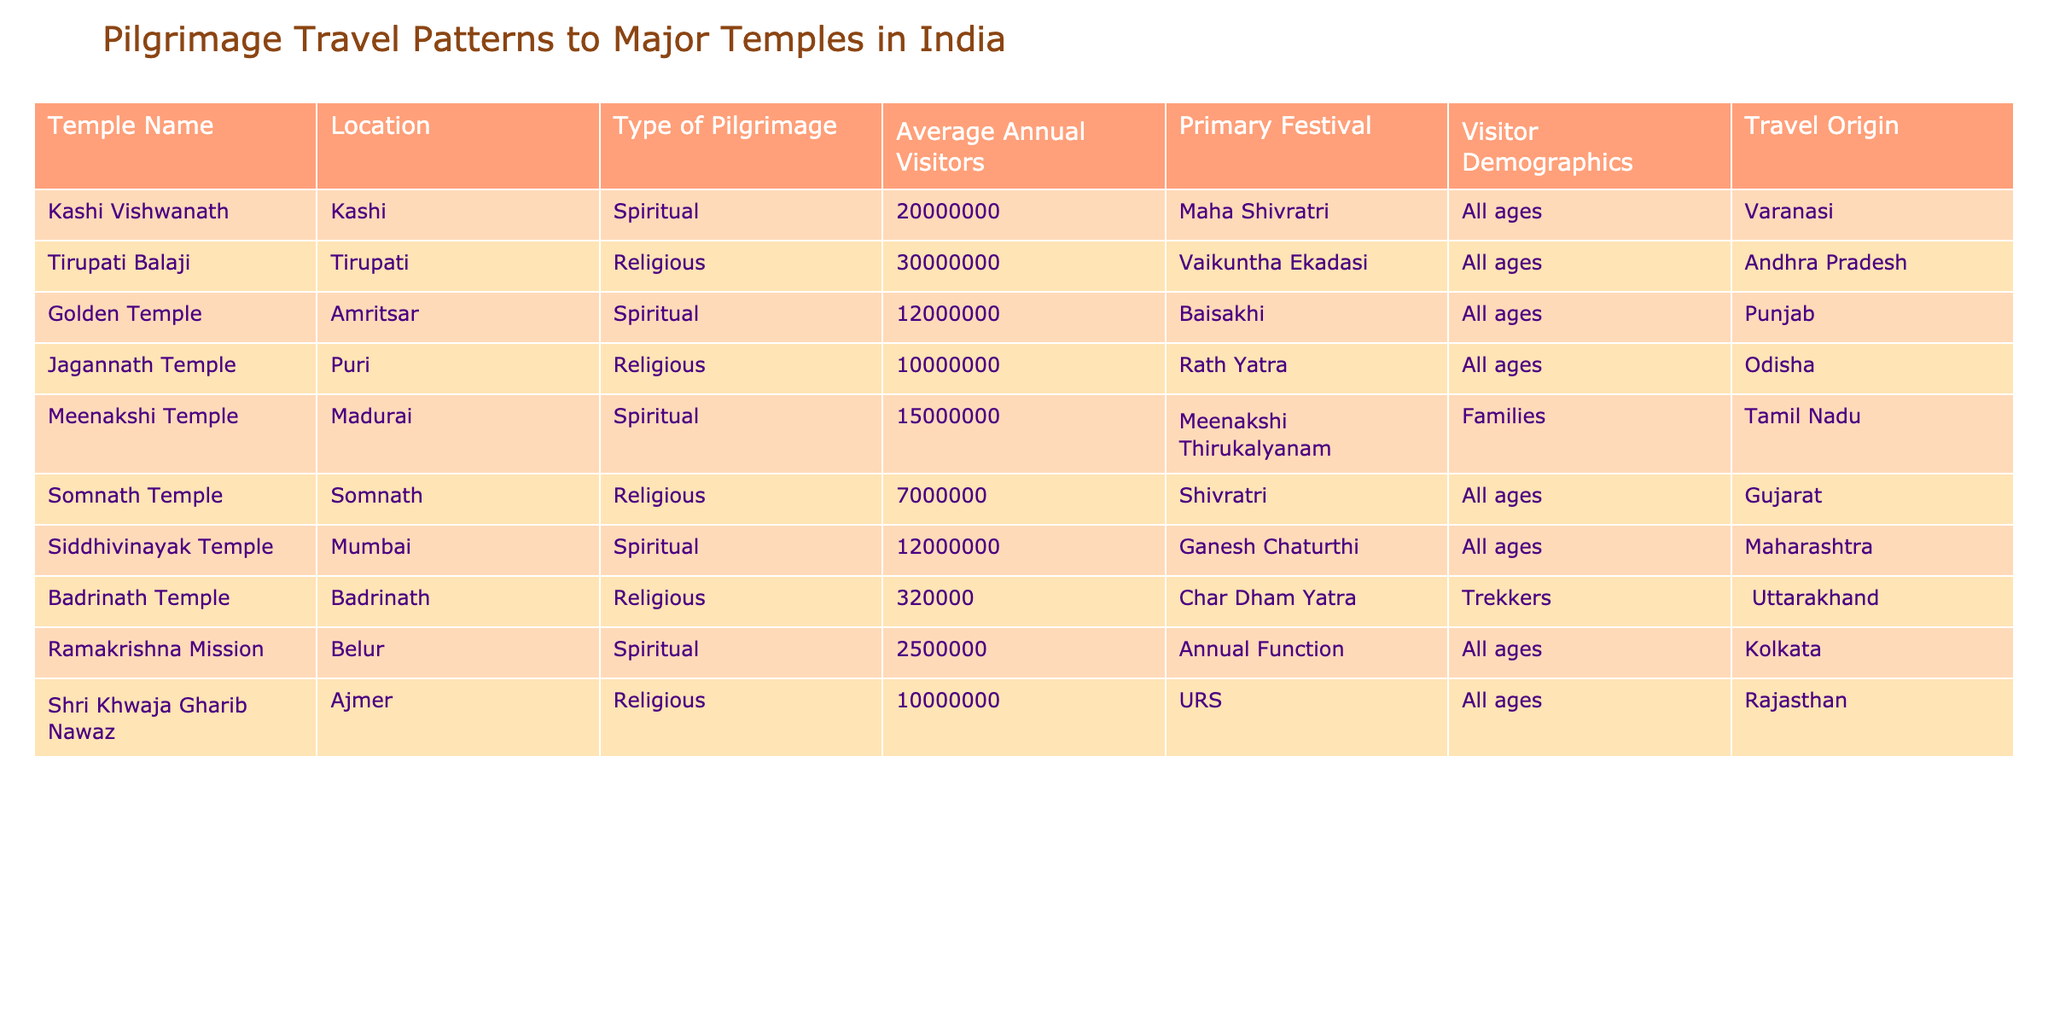What is the average annual visitor count for the Kashi Vishwanath Temple? The table states that the average annual visitors for the Kashi Vishwanath Temple are 20,000,000.
Answer: 20,000,000 Which temple has the highest average annual visitors? According to the data, the Tirupati Balaji Temple has the highest average annual visitors with 30,000,000.
Answer: Tirupati Balaji Is the visitor demographic for the Meenakshi Temple categorized as families? The Meenakshi Temple's visitor demographic is noted as families in the table.
Answer: Yes What is the total number of annual visitors for the Golden Temple and Jagannath Temple combined? The Golden Temple has 12,000,000 visitors and the Jagannath Temple has 10,000,000 visitors. Summing these gives 12,000,000 + 10,000,000 = 22,000,000.
Answer: 22,000,000 Which temple has the festival of Rath Yatra, and what is its annual visitor count? The Jagannath Temple is associated with the Rath Yatra festival and has an annual visitor count of 10,000,000.
Answer: Jagannath Temple, 10,000,000 How many temples listed have the visitor demographic categorized as "All ages"? After reviewing the table, the following temples have the visitor demographic categorized as "All ages": Kashi Vishwanath, Tirupati Balaji, Somnath Temple, Siddhivinayak Temple, Shri Khwaja Gharib Nawaz, and Ramakrishna Mission. Counting these, there are 6 temples.
Answer: 6 What is the difference in average annual visitors between the Tirupati Balaji Temple and the Somnath Temple? The Tirupati Balaji Temple has 30,000,000 visitors, while the Somnath Temple has 7,000,000. The difference is 30,000,000 - 7,000,000 = 23,000,000.
Answer: 23,000,000 Are there any temples with an average annual visitor count of less than 1,000,000? Examining the table, the lowest average annual visitor count is 320,000 for Badrinath Temple, which is below 1,000,000.
Answer: Yes Which temple located in Uttarakhand is visited mostly by trekkers? The temple located in Uttarakhand that is visited mostly by trekkers is the Badrinath Temple, with an average visitor count of 320,000.
Answer: Badrinath Temple 